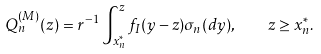Convert formula to latex. <formula><loc_0><loc_0><loc_500><loc_500>Q ^ { ( M ) } _ { n } ( z ) = r ^ { - 1 } \int _ { x _ { n } ^ { * } } ^ { z } f _ { I } ( y - z ) \sigma _ { n } ( d y ) , \quad z \geq x _ { n } ^ { * } .</formula> 